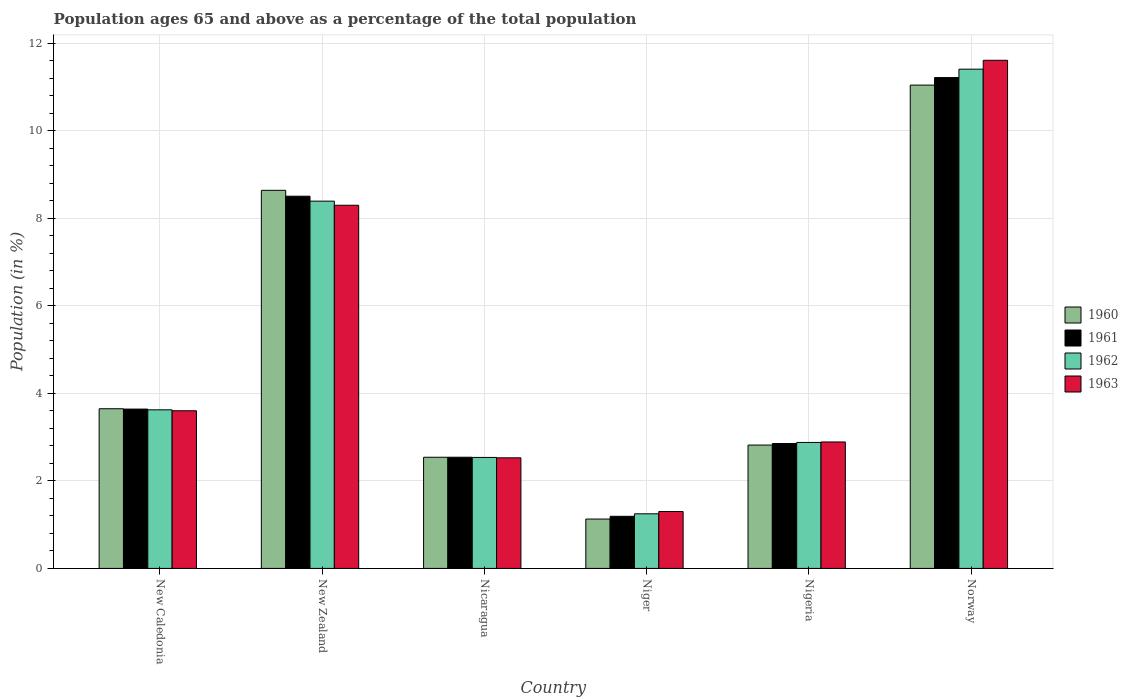How many different coloured bars are there?
Your answer should be compact. 4. How many groups of bars are there?
Offer a terse response. 6. Are the number of bars per tick equal to the number of legend labels?
Provide a short and direct response. Yes. Are the number of bars on each tick of the X-axis equal?
Your response must be concise. Yes. How many bars are there on the 1st tick from the left?
Your response must be concise. 4. What is the label of the 3rd group of bars from the left?
Your response must be concise. Nicaragua. What is the percentage of the population ages 65 and above in 1960 in Norway?
Ensure brevity in your answer.  11.05. Across all countries, what is the maximum percentage of the population ages 65 and above in 1963?
Keep it short and to the point. 11.62. Across all countries, what is the minimum percentage of the population ages 65 and above in 1962?
Give a very brief answer. 1.25. In which country was the percentage of the population ages 65 and above in 1961 minimum?
Your answer should be compact. Niger. What is the total percentage of the population ages 65 and above in 1962 in the graph?
Offer a very short reply. 30.1. What is the difference between the percentage of the population ages 65 and above in 1962 in Nicaragua and that in Nigeria?
Give a very brief answer. -0.34. What is the difference between the percentage of the population ages 65 and above in 1963 in Nigeria and the percentage of the population ages 65 and above in 1961 in Niger?
Provide a succinct answer. 1.7. What is the average percentage of the population ages 65 and above in 1963 per country?
Your answer should be very brief. 5.04. What is the difference between the percentage of the population ages 65 and above of/in 1963 and percentage of the population ages 65 and above of/in 1961 in Nigeria?
Give a very brief answer. 0.04. What is the ratio of the percentage of the population ages 65 and above in 1960 in New Caledonia to that in New Zealand?
Your answer should be very brief. 0.42. Is the difference between the percentage of the population ages 65 and above in 1963 in Nicaragua and Norway greater than the difference between the percentage of the population ages 65 and above in 1961 in Nicaragua and Norway?
Keep it short and to the point. No. What is the difference between the highest and the second highest percentage of the population ages 65 and above in 1960?
Provide a short and direct response. -2.41. What is the difference between the highest and the lowest percentage of the population ages 65 and above in 1960?
Offer a terse response. 9.92. In how many countries, is the percentage of the population ages 65 and above in 1960 greater than the average percentage of the population ages 65 and above in 1960 taken over all countries?
Ensure brevity in your answer.  2. What does the 3rd bar from the left in New Zealand represents?
Your response must be concise. 1962. Are all the bars in the graph horizontal?
Your response must be concise. No. What is the difference between two consecutive major ticks on the Y-axis?
Provide a succinct answer. 2. Are the values on the major ticks of Y-axis written in scientific E-notation?
Your answer should be compact. No. Does the graph contain any zero values?
Your response must be concise. No. Does the graph contain grids?
Offer a terse response. Yes. How many legend labels are there?
Provide a succinct answer. 4. What is the title of the graph?
Offer a very short reply. Population ages 65 and above as a percentage of the total population. What is the label or title of the Y-axis?
Ensure brevity in your answer.  Population (in %). What is the Population (in %) in 1960 in New Caledonia?
Offer a very short reply. 3.65. What is the Population (in %) of 1961 in New Caledonia?
Provide a short and direct response. 3.64. What is the Population (in %) in 1962 in New Caledonia?
Your answer should be very brief. 3.63. What is the Population (in %) of 1963 in New Caledonia?
Offer a very short reply. 3.6. What is the Population (in %) of 1960 in New Zealand?
Your response must be concise. 8.64. What is the Population (in %) of 1961 in New Zealand?
Your answer should be compact. 8.51. What is the Population (in %) of 1962 in New Zealand?
Provide a short and direct response. 8.4. What is the Population (in %) of 1963 in New Zealand?
Your response must be concise. 8.3. What is the Population (in %) of 1960 in Nicaragua?
Provide a short and direct response. 2.54. What is the Population (in %) in 1961 in Nicaragua?
Offer a very short reply. 2.54. What is the Population (in %) in 1962 in Nicaragua?
Keep it short and to the point. 2.54. What is the Population (in %) of 1963 in Nicaragua?
Ensure brevity in your answer.  2.53. What is the Population (in %) of 1960 in Niger?
Your response must be concise. 1.13. What is the Population (in %) of 1961 in Niger?
Your answer should be compact. 1.19. What is the Population (in %) of 1962 in Niger?
Provide a succinct answer. 1.25. What is the Population (in %) of 1963 in Niger?
Provide a succinct answer. 1.3. What is the Population (in %) in 1960 in Nigeria?
Your answer should be compact. 2.82. What is the Population (in %) of 1961 in Nigeria?
Your response must be concise. 2.85. What is the Population (in %) in 1962 in Nigeria?
Your answer should be very brief. 2.88. What is the Population (in %) in 1963 in Nigeria?
Ensure brevity in your answer.  2.89. What is the Population (in %) in 1960 in Norway?
Offer a terse response. 11.05. What is the Population (in %) of 1961 in Norway?
Provide a succinct answer. 11.22. What is the Population (in %) of 1962 in Norway?
Your answer should be compact. 11.41. What is the Population (in %) in 1963 in Norway?
Make the answer very short. 11.62. Across all countries, what is the maximum Population (in %) in 1960?
Keep it short and to the point. 11.05. Across all countries, what is the maximum Population (in %) in 1961?
Provide a succinct answer. 11.22. Across all countries, what is the maximum Population (in %) in 1962?
Provide a succinct answer. 11.41. Across all countries, what is the maximum Population (in %) in 1963?
Offer a terse response. 11.62. Across all countries, what is the minimum Population (in %) of 1960?
Provide a succinct answer. 1.13. Across all countries, what is the minimum Population (in %) in 1961?
Keep it short and to the point. 1.19. Across all countries, what is the minimum Population (in %) in 1962?
Provide a succinct answer. 1.25. Across all countries, what is the minimum Population (in %) of 1963?
Ensure brevity in your answer.  1.3. What is the total Population (in %) in 1960 in the graph?
Your answer should be very brief. 29.83. What is the total Population (in %) of 1961 in the graph?
Your answer should be compact. 29.96. What is the total Population (in %) of 1962 in the graph?
Give a very brief answer. 30.1. What is the total Population (in %) in 1963 in the graph?
Give a very brief answer. 30.24. What is the difference between the Population (in %) of 1960 in New Caledonia and that in New Zealand?
Your response must be concise. -4.99. What is the difference between the Population (in %) in 1961 in New Caledonia and that in New Zealand?
Provide a short and direct response. -4.87. What is the difference between the Population (in %) in 1962 in New Caledonia and that in New Zealand?
Keep it short and to the point. -4.77. What is the difference between the Population (in %) of 1963 in New Caledonia and that in New Zealand?
Provide a succinct answer. -4.7. What is the difference between the Population (in %) in 1960 in New Caledonia and that in Nicaragua?
Your answer should be compact. 1.11. What is the difference between the Population (in %) of 1961 in New Caledonia and that in Nicaragua?
Ensure brevity in your answer.  1.1. What is the difference between the Population (in %) in 1962 in New Caledonia and that in Nicaragua?
Provide a short and direct response. 1.09. What is the difference between the Population (in %) of 1963 in New Caledonia and that in Nicaragua?
Your answer should be compact. 1.08. What is the difference between the Population (in %) of 1960 in New Caledonia and that in Niger?
Keep it short and to the point. 2.52. What is the difference between the Population (in %) in 1961 in New Caledonia and that in Niger?
Keep it short and to the point. 2.45. What is the difference between the Population (in %) of 1962 in New Caledonia and that in Niger?
Offer a very short reply. 2.38. What is the difference between the Population (in %) of 1963 in New Caledonia and that in Niger?
Ensure brevity in your answer.  2.3. What is the difference between the Population (in %) of 1960 in New Caledonia and that in Nigeria?
Your answer should be very brief. 0.83. What is the difference between the Population (in %) of 1961 in New Caledonia and that in Nigeria?
Your response must be concise. 0.79. What is the difference between the Population (in %) in 1962 in New Caledonia and that in Nigeria?
Offer a terse response. 0.75. What is the difference between the Population (in %) of 1963 in New Caledonia and that in Nigeria?
Your answer should be very brief. 0.71. What is the difference between the Population (in %) of 1960 in New Caledonia and that in Norway?
Ensure brevity in your answer.  -7.4. What is the difference between the Population (in %) of 1961 in New Caledonia and that in Norway?
Keep it short and to the point. -7.58. What is the difference between the Population (in %) of 1962 in New Caledonia and that in Norway?
Give a very brief answer. -7.79. What is the difference between the Population (in %) in 1963 in New Caledonia and that in Norway?
Make the answer very short. -8.01. What is the difference between the Population (in %) of 1960 in New Zealand and that in Nicaragua?
Your response must be concise. 6.1. What is the difference between the Population (in %) of 1961 in New Zealand and that in Nicaragua?
Ensure brevity in your answer.  5.97. What is the difference between the Population (in %) of 1962 in New Zealand and that in Nicaragua?
Provide a succinct answer. 5.86. What is the difference between the Population (in %) of 1963 in New Zealand and that in Nicaragua?
Offer a very short reply. 5.77. What is the difference between the Population (in %) of 1960 in New Zealand and that in Niger?
Make the answer very short. 7.51. What is the difference between the Population (in %) in 1961 in New Zealand and that in Niger?
Provide a short and direct response. 7.32. What is the difference between the Population (in %) in 1962 in New Zealand and that in Niger?
Provide a short and direct response. 7.15. What is the difference between the Population (in %) of 1963 in New Zealand and that in Niger?
Offer a very short reply. 7. What is the difference between the Population (in %) of 1960 in New Zealand and that in Nigeria?
Your response must be concise. 5.82. What is the difference between the Population (in %) of 1961 in New Zealand and that in Nigeria?
Ensure brevity in your answer.  5.65. What is the difference between the Population (in %) in 1962 in New Zealand and that in Nigeria?
Offer a very short reply. 5.52. What is the difference between the Population (in %) in 1963 in New Zealand and that in Nigeria?
Offer a terse response. 5.41. What is the difference between the Population (in %) of 1960 in New Zealand and that in Norway?
Your answer should be very brief. -2.41. What is the difference between the Population (in %) in 1961 in New Zealand and that in Norway?
Offer a terse response. -2.71. What is the difference between the Population (in %) of 1962 in New Zealand and that in Norway?
Give a very brief answer. -3.02. What is the difference between the Population (in %) of 1963 in New Zealand and that in Norway?
Ensure brevity in your answer.  -3.31. What is the difference between the Population (in %) in 1960 in Nicaragua and that in Niger?
Make the answer very short. 1.41. What is the difference between the Population (in %) of 1961 in Nicaragua and that in Niger?
Your answer should be very brief. 1.35. What is the difference between the Population (in %) in 1962 in Nicaragua and that in Niger?
Offer a very short reply. 1.29. What is the difference between the Population (in %) of 1963 in Nicaragua and that in Niger?
Make the answer very short. 1.23. What is the difference between the Population (in %) of 1960 in Nicaragua and that in Nigeria?
Provide a succinct answer. -0.28. What is the difference between the Population (in %) of 1961 in Nicaragua and that in Nigeria?
Your answer should be compact. -0.31. What is the difference between the Population (in %) in 1962 in Nicaragua and that in Nigeria?
Your answer should be compact. -0.34. What is the difference between the Population (in %) of 1963 in Nicaragua and that in Nigeria?
Keep it short and to the point. -0.36. What is the difference between the Population (in %) in 1960 in Nicaragua and that in Norway?
Your answer should be very brief. -8.51. What is the difference between the Population (in %) in 1961 in Nicaragua and that in Norway?
Give a very brief answer. -8.68. What is the difference between the Population (in %) in 1962 in Nicaragua and that in Norway?
Keep it short and to the point. -8.88. What is the difference between the Population (in %) in 1963 in Nicaragua and that in Norway?
Give a very brief answer. -9.09. What is the difference between the Population (in %) in 1960 in Niger and that in Nigeria?
Your response must be concise. -1.69. What is the difference between the Population (in %) in 1961 in Niger and that in Nigeria?
Your answer should be compact. -1.66. What is the difference between the Population (in %) of 1962 in Niger and that in Nigeria?
Your response must be concise. -1.63. What is the difference between the Population (in %) in 1963 in Niger and that in Nigeria?
Your answer should be very brief. -1.59. What is the difference between the Population (in %) in 1960 in Niger and that in Norway?
Offer a very short reply. -9.92. What is the difference between the Population (in %) in 1961 in Niger and that in Norway?
Your answer should be compact. -10.03. What is the difference between the Population (in %) of 1962 in Niger and that in Norway?
Keep it short and to the point. -10.16. What is the difference between the Population (in %) of 1963 in Niger and that in Norway?
Offer a very short reply. -10.31. What is the difference between the Population (in %) of 1960 in Nigeria and that in Norway?
Your answer should be very brief. -8.23. What is the difference between the Population (in %) of 1961 in Nigeria and that in Norway?
Give a very brief answer. -8.37. What is the difference between the Population (in %) in 1962 in Nigeria and that in Norway?
Ensure brevity in your answer.  -8.53. What is the difference between the Population (in %) in 1963 in Nigeria and that in Norway?
Ensure brevity in your answer.  -8.72. What is the difference between the Population (in %) of 1960 in New Caledonia and the Population (in %) of 1961 in New Zealand?
Offer a very short reply. -4.86. What is the difference between the Population (in %) in 1960 in New Caledonia and the Population (in %) in 1962 in New Zealand?
Ensure brevity in your answer.  -4.75. What is the difference between the Population (in %) of 1960 in New Caledonia and the Population (in %) of 1963 in New Zealand?
Offer a terse response. -4.65. What is the difference between the Population (in %) in 1961 in New Caledonia and the Population (in %) in 1962 in New Zealand?
Offer a terse response. -4.75. What is the difference between the Population (in %) of 1961 in New Caledonia and the Population (in %) of 1963 in New Zealand?
Make the answer very short. -4.66. What is the difference between the Population (in %) in 1962 in New Caledonia and the Population (in %) in 1963 in New Zealand?
Give a very brief answer. -4.68. What is the difference between the Population (in %) of 1960 in New Caledonia and the Population (in %) of 1961 in Nicaragua?
Your answer should be compact. 1.11. What is the difference between the Population (in %) of 1960 in New Caledonia and the Population (in %) of 1962 in Nicaragua?
Your answer should be very brief. 1.11. What is the difference between the Population (in %) in 1960 in New Caledonia and the Population (in %) in 1963 in Nicaragua?
Provide a succinct answer. 1.12. What is the difference between the Population (in %) in 1961 in New Caledonia and the Population (in %) in 1962 in Nicaragua?
Ensure brevity in your answer.  1.11. What is the difference between the Population (in %) in 1961 in New Caledonia and the Population (in %) in 1963 in Nicaragua?
Offer a terse response. 1.11. What is the difference between the Population (in %) in 1962 in New Caledonia and the Population (in %) in 1963 in Nicaragua?
Your answer should be very brief. 1.1. What is the difference between the Population (in %) in 1960 in New Caledonia and the Population (in %) in 1961 in Niger?
Ensure brevity in your answer.  2.46. What is the difference between the Population (in %) of 1960 in New Caledonia and the Population (in %) of 1962 in Niger?
Keep it short and to the point. 2.4. What is the difference between the Population (in %) of 1960 in New Caledonia and the Population (in %) of 1963 in Niger?
Give a very brief answer. 2.35. What is the difference between the Population (in %) of 1961 in New Caledonia and the Population (in %) of 1962 in Niger?
Provide a short and direct response. 2.39. What is the difference between the Population (in %) in 1961 in New Caledonia and the Population (in %) in 1963 in Niger?
Ensure brevity in your answer.  2.34. What is the difference between the Population (in %) in 1962 in New Caledonia and the Population (in %) in 1963 in Niger?
Provide a succinct answer. 2.32. What is the difference between the Population (in %) in 1960 in New Caledonia and the Population (in %) in 1961 in Nigeria?
Your response must be concise. 0.8. What is the difference between the Population (in %) of 1960 in New Caledonia and the Population (in %) of 1962 in Nigeria?
Give a very brief answer. 0.77. What is the difference between the Population (in %) of 1960 in New Caledonia and the Population (in %) of 1963 in Nigeria?
Provide a succinct answer. 0.76. What is the difference between the Population (in %) of 1961 in New Caledonia and the Population (in %) of 1962 in Nigeria?
Offer a very short reply. 0.76. What is the difference between the Population (in %) in 1961 in New Caledonia and the Population (in %) in 1963 in Nigeria?
Ensure brevity in your answer.  0.75. What is the difference between the Population (in %) in 1962 in New Caledonia and the Population (in %) in 1963 in Nigeria?
Give a very brief answer. 0.73. What is the difference between the Population (in %) of 1960 in New Caledonia and the Population (in %) of 1961 in Norway?
Make the answer very short. -7.57. What is the difference between the Population (in %) of 1960 in New Caledonia and the Population (in %) of 1962 in Norway?
Your answer should be very brief. -7.76. What is the difference between the Population (in %) in 1960 in New Caledonia and the Population (in %) in 1963 in Norway?
Your answer should be very brief. -7.97. What is the difference between the Population (in %) of 1961 in New Caledonia and the Population (in %) of 1962 in Norway?
Your answer should be compact. -7.77. What is the difference between the Population (in %) of 1961 in New Caledonia and the Population (in %) of 1963 in Norway?
Your response must be concise. -7.97. What is the difference between the Population (in %) in 1962 in New Caledonia and the Population (in %) in 1963 in Norway?
Give a very brief answer. -7.99. What is the difference between the Population (in %) of 1960 in New Zealand and the Population (in %) of 1961 in Nicaragua?
Ensure brevity in your answer.  6.1. What is the difference between the Population (in %) in 1960 in New Zealand and the Population (in %) in 1962 in Nicaragua?
Make the answer very short. 6.11. What is the difference between the Population (in %) in 1960 in New Zealand and the Population (in %) in 1963 in Nicaragua?
Offer a terse response. 6.11. What is the difference between the Population (in %) of 1961 in New Zealand and the Population (in %) of 1962 in Nicaragua?
Offer a very short reply. 5.97. What is the difference between the Population (in %) in 1961 in New Zealand and the Population (in %) in 1963 in Nicaragua?
Ensure brevity in your answer.  5.98. What is the difference between the Population (in %) of 1962 in New Zealand and the Population (in %) of 1963 in Nicaragua?
Ensure brevity in your answer.  5.87. What is the difference between the Population (in %) in 1960 in New Zealand and the Population (in %) in 1961 in Niger?
Provide a succinct answer. 7.45. What is the difference between the Population (in %) of 1960 in New Zealand and the Population (in %) of 1962 in Niger?
Your response must be concise. 7.39. What is the difference between the Population (in %) of 1960 in New Zealand and the Population (in %) of 1963 in Niger?
Provide a succinct answer. 7.34. What is the difference between the Population (in %) of 1961 in New Zealand and the Population (in %) of 1962 in Niger?
Your answer should be very brief. 7.26. What is the difference between the Population (in %) in 1961 in New Zealand and the Population (in %) in 1963 in Niger?
Ensure brevity in your answer.  7.21. What is the difference between the Population (in %) of 1962 in New Zealand and the Population (in %) of 1963 in Niger?
Keep it short and to the point. 7.09. What is the difference between the Population (in %) in 1960 in New Zealand and the Population (in %) in 1961 in Nigeria?
Ensure brevity in your answer.  5.79. What is the difference between the Population (in %) in 1960 in New Zealand and the Population (in %) in 1962 in Nigeria?
Provide a short and direct response. 5.76. What is the difference between the Population (in %) in 1960 in New Zealand and the Population (in %) in 1963 in Nigeria?
Your response must be concise. 5.75. What is the difference between the Population (in %) of 1961 in New Zealand and the Population (in %) of 1962 in Nigeria?
Keep it short and to the point. 5.63. What is the difference between the Population (in %) in 1961 in New Zealand and the Population (in %) in 1963 in Nigeria?
Offer a terse response. 5.62. What is the difference between the Population (in %) of 1962 in New Zealand and the Population (in %) of 1963 in Nigeria?
Offer a terse response. 5.5. What is the difference between the Population (in %) of 1960 in New Zealand and the Population (in %) of 1961 in Norway?
Provide a short and direct response. -2.58. What is the difference between the Population (in %) in 1960 in New Zealand and the Population (in %) in 1962 in Norway?
Your response must be concise. -2.77. What is the difference between the Population (in %) of 1960 in New Zealand and the Population (in %) of 1963 in Norway?
Give a very brief answer. -2.97. What is the difference between the Population (in %) in 1961 in New Zealand and the Population (in %) in 1962 in Norway?
Your answer should be very brief. -2.9. What is the difference between the Population (in %) of 1961 in New Zealand and the Population (in %) of 1963 in Norway?
Offer a terse response. -3.11. What is the difference between the Population (in %) in 1962 in New Zealand and the Population (in %) in 1963 in Norway?
Ensure brevity in your answer.  -3.22. What is the difference between the Population (in %) of 1960 in Nicaragua and the Population (in %) of 1961 in Niger?
Your answer should be very brief. 1.35. What is the difference between the Population (in %) of 1960 in Nicaragua and the Population (in %) of 1962 in Niger?
Offer a very short reply. 1.29. What is the difference between the Population (in %) in 1960 in Nicaragua and the Population (in %) in 1963 in Niger?
Ensure brevity in your answer.  1.24. What is the difference between the Population (in %) in 1961 in Nicaragua and the Population (in %) in 1962 in Niger?
Ensure brevity in your answer.  1.29. What is the difference between the Population (in %) of 1961 in Nicaragua and the Population (in %) of 1963 in Niger?
Your answer should be very brief. 1.24. What is the difference between the Population (in %) in 1962 in Nicaragua and the Population (in %) in 1963 in Niger?
Ensure brevity in your answer.  1.24. What is the difference between the Population (in %) of 1960 in Nicaragua and the Population (in %) of 1961 in Nigeria?
Offer a very short reply. -0.31. What is the difference between the Population (in %) of 1960 in Nicaragua and the Population (in %) of 1962 in Nigeria?
Offer a terse response. -0.34. What is the difference between the Population (in %) of 1960 in Nicaragua and the Population (in %) of 1963 in Nigeria?
Your response must be concise. -0.35. What is the difference between the Population (in %) in 1961 in Nicaragua and the Population (in %) in 1962 in Nigeria?
Provide a short and direct response. -0.34. What is the difference between the Population (in %) in 1961 in Nicaragua and the Population (in %) in 1963 in Nigeria?
Your answer should be very brief. -0.35. What is the difference between the Population (in %) of 1962 in Nicaragua and the Population (in %) of 1963 in Nigeria?
Provide a short and direct response. -0.35. What is the difference between the Population (in %) of 1960 in Nicaragua and the Population (in %) of 1961 in Norway?
Ensure brevity in your answer.  -8.68. What is the difference between the Population (in %) in 1960 in Nicaragua and the Population (in %) in 1962 in Norway?
Offer a very short reply. -8.87. What is the difference between the Population (in %) in 1960 in Nicaragua and the Population (in %) in 1963 in Norway?
Offer a very short reply. -9.07. What is the difference between the Population (in %) of 1961 in Nicaragua and the Population (in %) of 1962 in Norway?
Make the answer very short. -8.87. What is the difference between the Population (in %) in 1961 in Nicaragua and the Population (in %) in 1963 in Norway?
Offer a very short reply. -9.07. What is the difference between the Population (in %) in 1962 in Nicaragua and the Population (in %) in 1963 in Norway?
Provide a short and direct response. -9.08. What is the difference between the Population (in %) in 1960 in Niger and the Population (in %) in 1961 in Nigeria?
Ensure brevity in your answer.  -1.73. What is the difference between the Population (in %) in 1960 in Niger and the Population (in %) in 1962 in Nigeria?
Your response must be concise. -1.75. What is the difference between the Population (in %) of 1960 in Niger and the Population (in %) of 1963 in Nigeria?
Ensure brevity in your answer.  -1.76. What is the difference between the Population (in %) of 1961 in Niger and the Population (in %) of 1962 in Nigeria?
Offer a terse response. -1.69. What is the difference between the Population (in %) in 1961 in Niger and the Population (in %) in 1963 in Nigeria?
Offer a terse response. -1.7. What is the difference between the Population (in %) of 1962 in Niger and the Population (in %) of 1963 in Nigeria?
Your answer should be compact. -1.64. What is the difference between the Population (in %) in 1960 in Niger and the Population (in %) in 1961 in Norway?
Your answer should be very brief. -10.09. What is the difference between the Population (in %) in 1960 in Niger and the Population (in %) in 1962 in Norway?
Offer a very short reply. -10.28. What is the difference between the Population (in %) of 1960 in Niger and the Population (in %) of 1963 in Norway?
Your answer should be very brief. -10.49. What is the difference between the Population (in %) of 1961 in Niger and the Population (in %) of 1962 in Norway?
Give a very brief answer. -10.22. What is the difference between the Population (in %) in 1961 in Niger and the Population (in %) in 1963 in Norway?
Provide a succinct answer. -10.42. What is the difference between the Population (in %) in 1962 in Niger and the Population (in %) in 1963 in Norway?
Provide a succinct answer. -10.37. What is the difference between the Population (in %) in 1960 in Nigeria and the Population (in %) in 1961 in Norway?
Provide a succinct answer. -8.4. What is the difference between the Population (in %) of 1960 in Nigeria and the Population (in %) of 1962 in Norway?
Offer a terse response. -8.59. What is the difference between the Population (in %) in 1960 in Nigeria and the Population (in %) in 1963 in Norway?
Make the answer very short. -8.8. What is the difference between the Population (in %) of 1961 in Nigeria and the Population (in %) of 1962 in Norway?
Provide a short and direct response. -8.56. What is the difference between the Population (in %) in 1961 in Nigeria and the Population (in %) in 1963 in Norway?
Keep it short and to the point. -8.76. What is the difference between the Population (in %) of 1962 in Nigeria and the Population (in %) of 1963 in Norway?
Make the answer very short. -8.74. What is the average Population (in %) in 1960 per country?
Your answer should be compact. 4.97. What is the average Population (in %) in 1961 per country?
Keep it short and to the point. 4.99. What is the average Population (in %) of 1962 per country?
Provide a short and direct response. 5.02. What is the average Population (in %) of 1963 per country?
Provide a short and direct response. 5.04. What is the difference between the Population (in %) in 1960 and Population (in %) in 1961 in New Caledonia?
Provide a succinct answer. 0.01. What is the difference between the Population (in %) in 1960 and Population (in %) in 1962 in New Caledonia?
Your response must be concise. 0.02. What is the difference between the Population (in %) in 1960 and Population (in %) in 1963 in New Caledonia?
Your answer should be compact. 0.05. What is the difference between the Population (in %) in 1961 and Population (in %) in 1962 in New Caledonia?
Your answer should be compact. 0.02. What is the difference between the Population (in %) in 1961 and Population (in %) in 1963 in New Caledonia?
Make the answer very short. 0.04. What is the difference between the Population (in %) of 1962 and Population (in %) of 1963 in New Caledonia?
Ensure brevity in your answer.  0.02. What is the difference between the Population (in %) in 1960 and Population (in %) in 1961 in New Zealand?
Your response must be concise. 0.13. What is the difference between the Population (in %) in 1960 and Population (in %) in 1962 in New Zealand?
Make the answer very short. 0.25. What is the difference between the Population (in %) in 1960 and Population (in %) in 1963 in New Zealand?
Provide a short and direct response. 0.34. What is the difference between the Population (in %) of 1961 and Population (in %) of 1962 in New Zealand?
Give a very brief answer. 0.11. What is the difference between the Population (in %) of 1961 and Population (in %) of 1963 in New Zealand?
Make the answer very short. 0.21. What is the difference between the Population (in %) in 1962 and Population (in %) in 1963 in New Zealand?
Your response must be concise. 0.09. What is the difference between the Population (in %) in 1960 and Population (in %) in 1961 in Nicaragua?
Provide a short and direct response. -0. What is the difference between the Population (in %) in 1960 and Population (in %) in 1962 in Nicaragua?
Keep it short and to the point. 0. What is the difference between the Population (in %) of 1960 and Population (in %) of 1963 in Nicaragua?
Your response must be concise. 0.01. What is the difference between the Population (in %) in 1961 and Population (in %) in 1962 in Nicaragua?
Your response must be concise. 0. What is the difference between the Population (in %) in 1961 and Population (in %) in 1963 in Nicaragua?
Keep it short and to the point. 0.01. What is the difference between the Population (in %) in 1962 and Population (in %) in 1963 in Nicaragua?
Ensure brevity in your answer.  0.01. What is the difference between the Population (in %) in 1960 and Population (in %) in 1961 in Niger?
Ensure brevity in your answer.  -0.06. What is the difference between the Population (in %) in 1960 and Population (in %) in 1962 in Niger?
Give a very brief answer. -0.12. What is the difference between the Population (in %) in 1960 and Population (in %) in 1963 in Niger?
Provide a short and direct response. -0.17. What is the difference between the Population (in %) of 1961 and Population (in %) of 1962 in Niger?
Ensure brevity in your answer.  -0.06. What is the difference between the Population (in %) in 1961 and Population (in %) in 1963 in Niger?
Make the answer very short. -0.11. What is the difference between the Population (in %) in 1962 and Population (in %) in 1963 in Niger?
Your answer should be very brief. -0.05. What is the difference between the Population (in %) in 1960 and Population (in %) in 1961 in Nigeria?
Your answer should be compact. -0.04. What is the difference between the Population (in %) of 1960 and Population (in %) of 1962 in Nigeria?
Your answer should be compact. -0.06. What is the difference between the Population (in %) of 1960 and Population (in %) of 1963 in Nigeria?
Your answer should be compact. -0.07. What is the difference between the Population (in %) in 1961 and Population (in %) in 1962 in Nigeria?
Your answer should be compact. -0.02. What is the difference between the Population (in %) in 1961 and Population (in %) in 1963 in Nigeria?
Offer a terse response. -0.04. What is the difference between the Population (in %) of 1962 and Population (in %) of 1963 in Nigeria?
Your answer should be very brief. -0.01. What is the difference between the Population (in %) of 1960 and Population (in %) of 1961 in Norway?
Give a very brief answer. -0.17. What is the difference between the Population (in %) of 1960 and Population (in %) of 1962 in Norway?
Your answer should be very brief. -0.36. What is the difference between the Population (in %) of 1960 and Population (in %) of 1963 in Norway?
Make the answer very short. -0.57. What is the difference between the Population (in %) of 1961 and Population (in %) of 1962 in Norway?
Your response must be concise. -0.19. What is the difference between the Population (in %) of 1961 and Population (in %) of 1963 in Norway?
Keep it short and to the point. -0.4. What is the difference between the Population (in %) of 1962 and Population (in %) of 1963 in Norway?
Provide a succinct answer. -0.2. What is the ratio of the Population (in %) of 1960 in New Caledonia to that in New Zealand?
Your answer should be very brief. 0.42. What is the ratio of the Population (in %) of 1961 in New Caledonia to that in New Zealand?
Ensure brevity in your answer.  0.43. What is the ratio of the Population (in %) in 1962 in New Caledonia to that in New Zealand?
Your answer should be compact. 0.43. What is the ratio of the Population (in %) of 1963 in New Caledonia to that in New Zealand?
Provide a short and direct response. 0.43. What is the ratio of the Population (in %) in 1960 in New Caledonia to that in Nicaragua?
Give a very brief answer. 1.44. What is the ratio of the Population (in %) of 1961 in New Caledonia to that in Nicaragua?
Give a very brief answer. 1.43. What is the ratio of the Population (in %) in 1962 in New Caledonia to that in Nicaragua?
Offer a very short reply. 1.43. What is the ratio of the Population (in %) of 1963 in New Caledonia to that in Nicaragua?
Your answer should be compact. 1.43. What is the ratio of the Population (in %) in 1960 in New Caledonia to that in Niger?
Your response must be concise. 3.23. What is the ratio of the Population (in %) of 1961 in New Caledonia to that in Niger?
Offer a very short reply. 3.06. What is the ratio of the Population (in %) in 1962 in New Caledonia to that in Niger?
Your response must be concise. 2.9. What is the ratio of the Population (in %) in 1963 in New Caledonia to that in Niger?
Your response must be concise. 2.77. What is the ratio of the Population (in %) in 1960 in New Caledonia to that in Nigeria?
Provide a succinct answer. 1.29. What is the ratio of the Population (in %) in 1961 in New Caledonia to that in Nigeria?
Ensure brevity in your answer.  1.28. What is the ratio of the Population (in %) of 1962 in New Caledonia to that in Nigeria?
Give a very brief answer. 1.26. What is the ratio of the Population (in %) of 1963 in New Caledonia to that in Nigeria?
Provide a short and direct response. 1.25. What is the ratio of the Population (in %) in 1960 in New Caledonia to that in Norway?
Offer a very short reply. 0.33. What is the ratio of the Population (in %) in 1961 in New Caledonia to that in Norway?
Your answer should be very brief. 0.32. What is the ratio of the Population (in %) in 1962 in New Caledonia to that in Norway?
Offer a very short reply. 0.32. What is the ratio of the Population (in %) of 1963 in New Caledonia to that in Norway?
Offer a terse response. 0.31. What is the ratio of the Population (in %) of 1960 in New Zealand to that in Nicaragua?
Offer a very short reply. 3.4. What is the ratio of the Population (in %) in 1961 in New Zealand to that in Nicaragua?
Offer a terse response. 3.35. What is the ratio of the Population (in %) of 1962 in New Zealand to that in Nicaragua?
Your answer should be very brief. 3.31. What is the ratio of the Population (in %) in 1963 in New Zealand to that in Nicaragua?
Ensure brevity in your answer.  3.28. What is the ratio of the Population (in %) in 1960 in New Zealand to that in Niger?
Your answer should be compact. 7.66. What is the ratio of the Population (in %) of 1961 in New Zealand to that in Niger?
Your answer should be very brief. 7.14. What is the ratio of the Population (in %) of 1962 in New Zealand to that in Niger?
Your answer should be very brief. 6.73. What is the ratio of the Population (in %) in 1963 in New Zealand to that in Niger?
Your response must be concise. 6.38. What is the ratio of the Population (in %) of 1960 in New Zealand to that in Nigeria?
Your answer should be very brief. 3.07. What is the ratio of the Population (in %) in 1961 in New Zealand to that in Nigeria?
Ensure brevity in your answer.  2.98. What is the ratio of the Population (in %) in 1962 in New Zealand to that in Nigeria?
Provide a succinct answer. 2.92. What is the ratio of the Population (in %) of 1963 in New Zealand to that in Nigeria?
Ensure brevity in your answer.  2.87. What is the ratio of the Population (in %) in 1960 in New Zealand to that in Norway?
Offer a terse response. 0.78. What is the ratio of the Population (in %) of 1961 in New Zealand to that in Norway?
Give a very brief answer. 0.76. What is the ratio of the Population (in %) of 1962 in New Zealand to that in Norway?
Offer a terse response. 0.74. What is the ratio of the Population (in %) of 1963 in New Zealand to that in Norway?
Give a very brief answer. 0.71. What is the ratio of the Population (in %) of 1960 in Nicaragua to that in Niger?
Offer a terse response. 2.25. What is the ratio of the Population (in %) in 1961 in Nicaragua to that in Niger?
Make the answer very short. 2.13. What is the ratio of the Population (in %) in 1962 in Nicaragua to that in Niger?
Make the answer very short. 2.03. What is the ratio of the Population (in %) in 1963 in Nicaragua to that in Niger?
Make the answer very short. 1.94. What is the ratio of the Population (in %) in 1960 in Nicaragua to that in Nigeria?
Give a very brief answer. 0.9. What is the ratio of the Population (in %) of 1961 in Nicaragua to that in Nigeria?
Keep it short and to the point. 0.89. What is the ratio of the Population (in %) of 1962 in Nicaragua to that in Nigeria?
Ensure brevity in your answer.  0.88. What is the ratio of the Population (in %) in 1963 in Nicaragua to that in Nigeria?
Give a very brief answer. 0.87. What is the ratio of the Population (in %) in 1960 in Nicaragua to that in Norway?
Provide a short and direct response. 0.23. What is the ratio of the Population (in %) of 1961 in Nicaragua to that in Norway?
Provide a succinct answer. 0.23. What is the ratio of the Population (in %) of 1962 in Nicaragua to that in Norway?
Your answer should be compact. 0.22. What is the ratio of the Population (in %) of 1963 in Nicaragua to that in Norway?
Your response must be concise. 0.22. What is the ratio of the Population (in %) of 1960 in Niger to that in Nigeria?
Offer a very short reply. 0.4. What is the ratio of the Population (in %) in 1961 in Niger to that in Nigeria?
Offer a very short reply. 0.42. What is the ratio of the Population (in %) of 1962 in Niger to that in Nigeria?
Provide a short and direct response. 0.43. What is the ratio of the Population (in %) in 1963 in Niger to that in Nigeria?
Offer a very short reply. 0.45. What is the ratio of the Population (in %) of 1960 in Niger to that in Norway?
Ensure brevity in your answer.  0.1. What is the ratio of the Population (in %) in 1961 in Niger to that in Norway?
Your response must be concise. 0.11. What is the ratio of the Population (in %) in 1962 in Niger to that in Norway?
Give a very brief answer. 0.11. What is the ratio of the Population (in %) of 1963 in Niger to that in Norway?
Your response must be concise. 0.11. What is the ratio of the Population (in %) in 1960 in Nigeria to that in Norway?
Your response must be concise. 0.26. What is the ratio of the Population (in %) in 1961 in Nigeria to that in Norway?
Provide a short and direct response. 0.25. What is the ratio of the Population (in %) of 1962 in Nigeria to that in Norway?
Ensure brevity in your answer.  0.25. What is the ratio of the Population (in %) of 1963 in Nigeria to that in Norway?
Keep it short and to the point. 0.25. What is the difference between the highest and the second highest Population (in %) of 1960?
Your response must be concise. 2.41. What is the difference between the highest and the second highest Population (in %) in 1961?
Your answer should be compact. 2.71. What is the difference between the highest and the second highest Population (in %) in 1962?
Provide a short and direct response. 3.02. What is the difference between the highest and the second highest Population (in %) in 1963?
Provide a succinct answer. 3.31. What is the difference between the highest and the lowest Population (in %) of 1960?
Your answer should be compact. 9.92. What is the difference between the highest and the lowest Population (in %) of 1961?
Your answer should be very brief. 10.03. What is the difference between the highest and the lowest Population (in %) of 1962?
Give a very brief answer. 10.16. What is the difference between the highest and the lowest Population (in %) in 1963?
Your answer should be very brief. 10.31. 